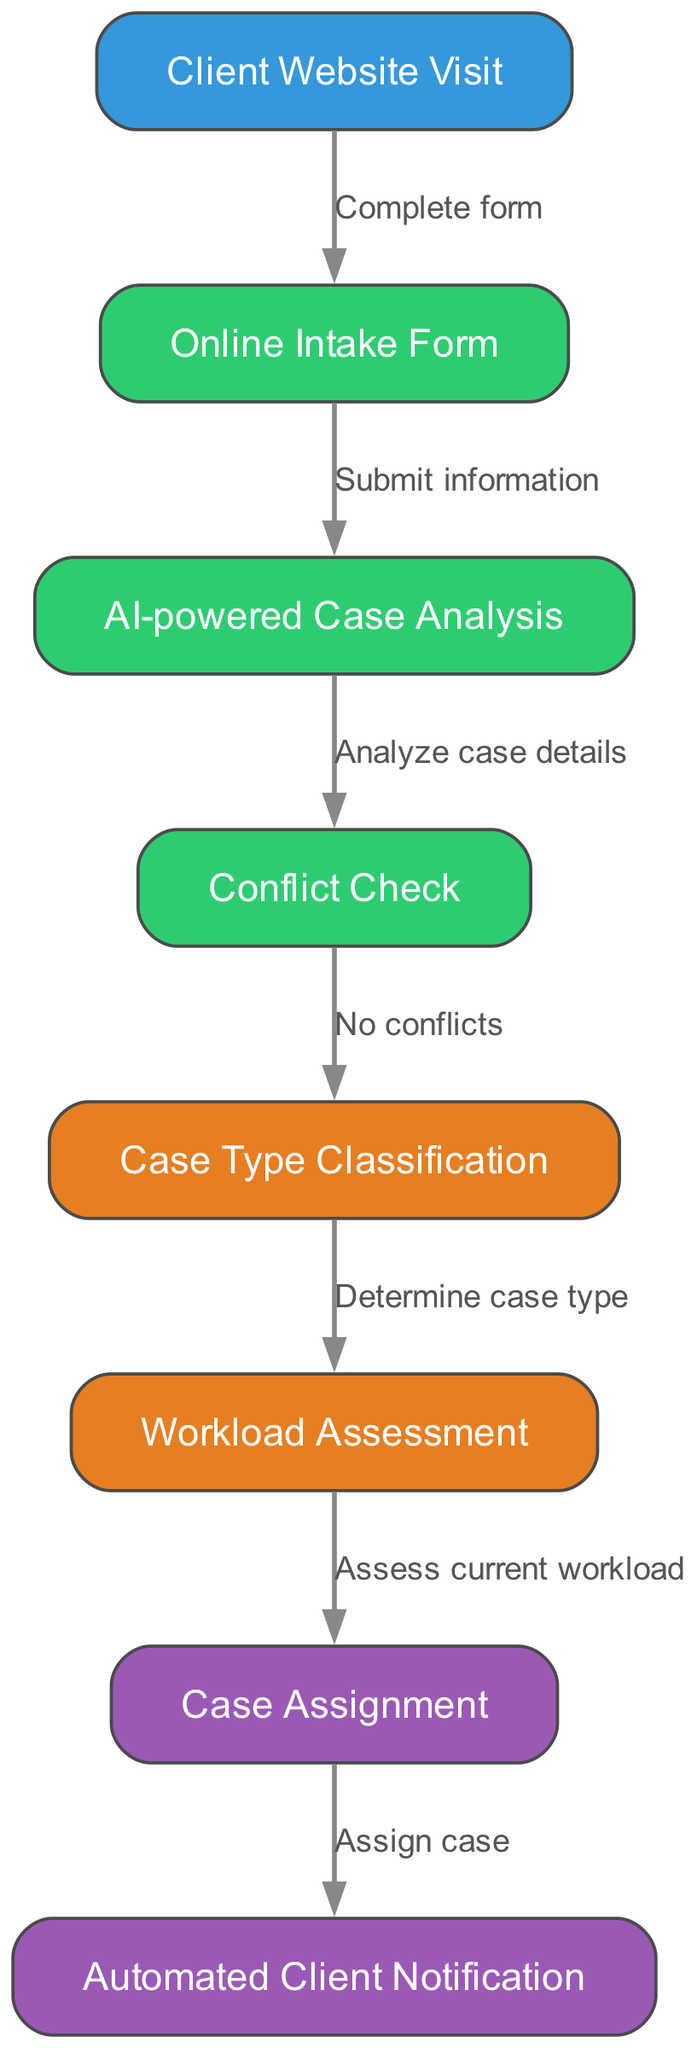What is the first step in the process? The diagram indicates that the first node is "Client Website Visit," which is where the process begins, representing the action of a client visiting the law practice's website.
Answer: Client Website Visit How many nodes are in the diagram? By counting the "nodes" section of the diagram data, it shows there are 8 distinct nodes, each representing a different step in the automated client intake and case assignment system.
Answer: 8 What step follows the "Online Intake Form"? The diagram shows that the next step after "Online Intake Form" is "AI-powered Case Analysis," which is reached by submitting the information from the form.
Answer: AI-powered Case Analysis What is the condition checked after "AI-powered Case Analysis"? According to the diagram, after "AI-powered Case Analysis," a "Conflict Check" is conducted to determine if there are any conflicts in handling the case.
Answer: Conflict Check Which node is linked to "Workload Assessment"? The diagram specifies that "Workload Assessment" is linked to "Case Type Classification," meaning that workload assessment occurs after determining the case type.
Answer: Case Type Classification Which node indicates client communication? The last step of the process is "Automated Client Notification," which implies client communication occurs when a case is assigned, signaling the end of the intake and assignment process.
Answer: Automated Client Notification What is the action taken after a "Conflict Check"? Following a "Conflict Check," the process proceeds to "Case Type Classification" if no conflicts are found, illustrating the flow of the intake system.
Answer: Case Type Classification Which node represents case assignment? The diagram reveals that the "Case Assignment" node is directly after "Workload Assessment," indicating this step is where cases are officially assigned to the attorney.
Answer: Case Assignment 